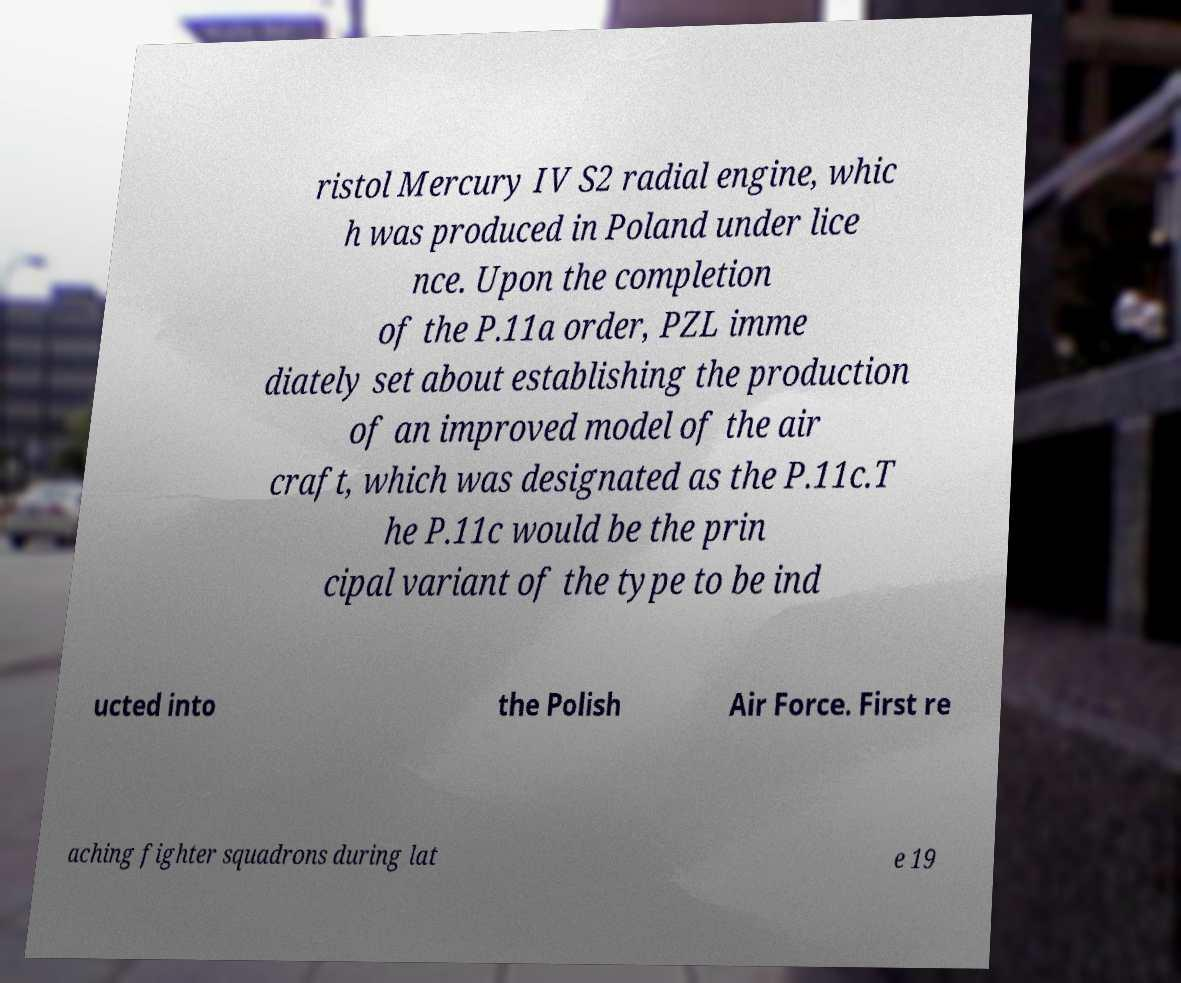There's text embedded in this image that I need extracted. Can you transcribe it verbatim? ristol Mercury IV S2 radial engine, whic h was produced in Poland under lice nce. Upon the completion of the P.11a order, PZL imme diately set about establishing the production of an improved model of the air craft, which was designated as the P.11c.T he P.11c would be the prin cipal variant of the type to be ind ucted into the Polish Air Force. First re aching fighter squadrons during lat e 19 